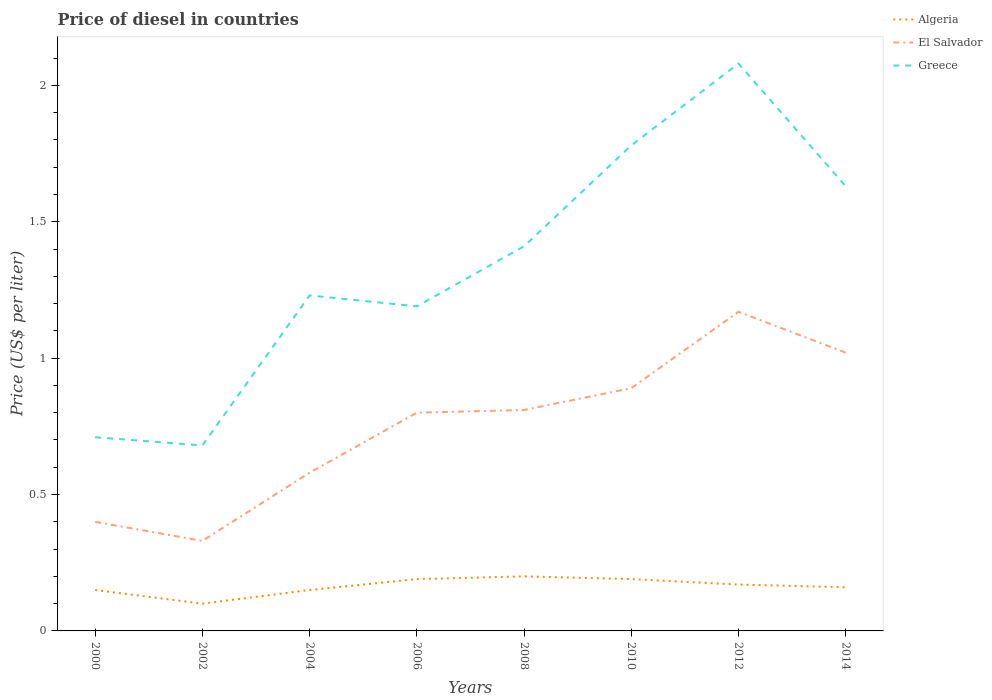How many different coloured lines are there?
Give a very brief answer. 3. Is the number of lines equal to the number of legend labels?
Make the answer very short. Yes. Across all years, what is the maximum price of diesel in Greece?
Your answer should be compact. 0.68. What is the total price of diesel in Algeria in the graph?
Your response must be concise. -0.01. Is the price of diesel in Algeria strictly greater than the price of diesel in Greece over the years?
Provide a short and direct response. Yes. How many lines are there?
Provide a succinct answer. 3. How many years are there in the graph?
Provide a short and direct response. 8. Are the values on the major ticks of Y-axis written in scientific E-notation?
Your answer should be compact. No. Does the graph contain any zero values?
Provide a succinct answer. No. Where does the legend appear in the graph?
Your response must be concise. Top right. How many legend labels are there?
Offer a very short reply. 3. How are the legend labels stacked?
Give a very brief answer. Vertical. What is the title of the graph?
Offer a terse response. Price of diesel in countries. Does "East Asia (developing only)" appear as one of the legend labels in the graph?
Your answer should be very brief. No. What is the label or title of the Y-axis?
Give a very brief answer. Price (US$ per liter). What is the Price (US$ per liter) in Algeria in 2000?
Your answer should be very brief. 0.15. What is the Price (US$ per liter) in Greece in 2000?
Provide a short and direct response. 0.71. What is the Price (US$ per liter) in El Salvador in 2002?
Your response must be concise. 0.33. What is the Price (US$ per liter) of Greece in 2002?
Offer a very short reply. 0.68. What is the Price (US$ per liter) in El Salvador in 2004?
Your answer should be very brief. 0.58. What is the Price (US$ per liter) in Greece in 2004?
Provide a short and direct response. 1.23. What is the Price (US$ per liter) in Algeria in 2006?
Keep it short and to the point. 0.19. What is the Price (US$ per liter) in Greece in 2006?
Your answer should be compact. 1.19. What is the Price (US$ per liter) of El Salvador in 2008?
Your answer should be very brief. 0.81. What is the Price (US$ per liter) in Greece in 2008?
Your response must be concise. 1.41. What is the Price (US$ per liter) in Algeria in 2010?
Provide a short and direct response. 0.19. What is the Price (US$ per liter) of El Salvador in 2010?
Your response must be concise. 0.89. What is the Price (US$ per liter) of Greece in 2010?
Provide a succinct answer. 1.78. What is the Price (US$ per liter) in Algeria in 2012?
Offer a very short reply. 0.17. What is the Price (US$ per liter) of El Salvador in 2012?
Give a very brief answer. 1.17. What is the Price (US$ per liter) in Greece in 2012?
Offer a terse response. 2.08. What is the Price (US$ per liter) in Algeria in 2014?
Ensure brevity in your answer.  0.16. What is the Price (US$ per liter) of El Salvador in 2014?
Your response must be concise. 1.02. What is the Price (US$ per liter) in Greece in 2014?
Provide a succinct answer. 1.63. Across all years, what is the maximum Price (US$ per liter) of El Salvador?
Make the answer very short. 1.17. Across all years, what is the maximum Price (US$ per liter) in Greece?
Provide a short and direct response. 2.08. Across all years, what is the minimum Price (US$ per liter) in Algeria?
Your response must be concise. 0.1. Across all years, what is the minimum Price (US$ per liter) of El Salvador?
Ensure brevity in your answer.  0.33. Across all years, what is the minimum Price (US$ per liter) of Greece?
Your answer should be compact. 0.68. What is the total Price (US$ per liter) of Algeria in the graph?
Your response must be concise. 1.31. What is the total Price (US$ per liter) in El Salvador in the graph?
Your answer should be compact. 6. What is the total Price (US$ per liter) in Greece in the graph?
Provide a short and direct response. 10.71. What is the difference between the Price (US$ per liter) of Algeria in 2000 and that in 2002?
Give a very brief answer. 0.05. What is the difference between the Price (US$ per liter) in El Salvador in 2000 and that in 2002?
Offer a terse response. 0.07. What is the difference between the Price (US$ per liter) in Greece in 2000 and that in 2002?
Your answer should be compact. 0.03. What is the difference between the Price (US$ per liter) of El Salvador in 2000 and that in 2004?
Offer a terse response. -0.18. What is the difference between the Price (US$ per liter) in Greece in 2000 and that in 2004?
Offer a terse response. -0.52. What is the difference between the Price (US$ per liter) of Algeria in 2000 and that in 2006?
Your answer should be very brief. -0.04. What is the difference between the Price (US$ per liter) of El Salvador in 2000 and that in 2006?
Keep it short and to the point. -0.4. What is the difference between the Price (US$ per liter) in Greece in 2000 and that in 2006?
Your answer should be compact. -0.48. What is the difference between the Price (US$ per liter) of El Salvador in 2000 and that in 2008?
Give a very brief answer. -0.41. What is the difference between the Price (US$ per liter) in Algeria in 2000 and that in 2010?
Keep it short and to the point. -0.04. What is the difference between the Price (US$ per liter) of El Salvador in 2000 and that in 2010?
Provide a succinct answer. -0.49. What is the difference between the Price (US$ per liter) of Greece in 2000 and that in 2010?
Offer a terse response. -1.07. What is the difference between the Price (US$ per liter) of Algeria in 2000 and that in 2012?
Offer a very short reply. -0.02. What is the difference between the Price (US$ per liter) in El Salvador in 2000 and that in 2012?
Provide a short and direct response. -0.77. What is the difference between the Price (US$ per liter) of Greece in 2000 and that in 2012?
Provide a succinct answer. -1.37. What is the difference between the Price (US$ per liter) of Algeria in 2000 and that in 2014?
Provide a succinct answer. -0.01. What is the difference between the Price (US$ per liter) of El Salvador in 2000 and that in 2014?
Provide a short and direct response. -0.62. What is the difference between the Price (US$ per liter) in Greece in 2000 and that in 2014?
Keep it short and to the point. -0.92. What is the difference between the Price (US$ per liter) in Algeria in 2002 and that in 2004?
Provide a short and direct response. -0.05. What is the difference between the Price (US$ per liter) in Greece in 2002 and that in 2004?
Offer a very short reply. -0.55. What is the difference between the Price (US$ per liter) of Algeria in 2002 and that in 2006?
Your response must be concise. -0.09. What is the difference between the Price (US$ per liter) in El Salvador in 2002 and that in 2006?
Make the answer very short. -0.47. What is the difference between the Price (US$ per liter) of Greece in 2002 and that in 2006?
Keep it short and to the point. -0.51. What is the difference between the Price (US$ per liter) in Algeria in 2002 and that in 2008?
Provide a succinct answer. -0.1. What is the difference between the Price (US$ per liter) of El Salvador in 2002 and that in 2008?
Give a very brief answer. -0.48. What is the difference between the Price (US$ per liter) in Greece in 2002 and that in 2008?
Ensure brevity in your answer.  -0.73. What is the difference between the Price (US$ per liter) in Algeria in 2002 and that in 2010?
Give a very brief answer. -0.09. What is the difference between the Price (US$ per liter) in El Salvador in 2002 and that in 2010?
Offer a terse response. -0.56. What is the difference between the Price (US$ per liter) of Algeria in 2002 and that in 2012?
Keep it short and to the point. -0.07. What is the difference between the Price (US$ per liter) in El Salvador in 2002 and that in 2012?
Offer a very short reply. -0.84. What is the difference between the Price (US$ per liter) of Greece in 2002 and that in 2012?
Provide a succinct answer. -1.4. What is the difference between the Price (US$ per liter) of Algeria in 2002 and that in 2014?
Your answer should be compact. -0.06. What is the difference between the Price (US$ per liter) in El Salvador in 2002 and that in 2014?
Keep it short and to the point. -0.69. What is the difference between the Price (US$ per liter) of Greece in 2002 and that in 2014?
Make the answer very short. -0.95. What is the difference between the Price (US$ per liter) of Algeria in 2004 and that in 2006?
Your response must be concise. -0.04. What is the difference between the Price (US$ per liter) of El Salvador in 2004 and that in 2006?
Provide a short and direct response. -0.22. What is the difference between the Price (US$ per liter) in El Salvador in 2004 and that in 2008?
Make the answer very short. -0.23. What is the difference between the Price (US$ per liter) in Greece in 2004 and that in 2008?
Keep it short and to the point. -0.18. What is the difference between the Price (US$ per liter) of Algeria in 2004 and that in 2010?
Make the answer very short. -0.04. What is the difference between the Price (US$ per liter) in El Salvador in 2004 and that in 2010?
Ensure brevity in your answer.  -0.31. What is the difference between the Price (US$ per liter) in Greece in 2004 and that in 2010?
Make the answer very short. -0.55. What is the difference between the Price (US$ per liter) in Algeria in 2004 and that in 2012?
Make the answer very short. -0.02. What is the difference between the Price (US$ per liter) in El Salvador in 2004 and that in 2012?
Keep it short and to the point. -0.59. What is the difference between the Price (US$ per liter) in Greece in 2004 and that in 2012?
Offer a very short reply. -0.85. What is the difference between the Price (US$ per liter) in Algeria in 2004 and that in 2014?
Your answer should be very brief. -0.01. What is the difference between the Price (US$ per liter) of El Salvador in 2004 and that in 2014?
Your answer should be compact. -0.44. What is the difference between the Price (US$ per liter) in Algeria in 2006 and that in 2008?
Provide a succinct answer. -0.01. What is the difference between the Price (US$ per liter) of El Salvador in 2006 and that in 2008?
Your answer should be compact. -0.01. What is the difference between the Price (US$ per liter) in Greece in 2006 and that in 2008?
Ensure brevity in your answer.  -0.22. What is the difference between the Price (US$ per liter) in Algeria in 2006 and that in 2010?
Keep it short and to the point. 0. What is the difference between the Price (US$ per liter) in El Salvador in 2006 and that in 2010?
Give a very brief answer. -0.09. What is the difference between the Price (US$ per liter) of Greece in 2006 and that in 2010?
Ensure brevity in your answer.  -0.59. What is the difference between the Price (US$ per liter) in Algeria in 2006 and that in 2012?
Ensure brevity in your answer.  0.02. What is the difference between the Price (US$ per liter) in El Salvador in 2006 and that in 2012?
Ensure brevity in your answer.  -0.37. What is the difference between the Price (US$ per liter) in Greece in 2006 and that in 2012?
Keep it short and to the point. -0.89. What is the difference between the Price (US$ per liter) of El Salvador in 2006 and that in 2014?
Your answer should be compact. -0.22. What is the difference between the Price (US$ per liter) in Greece in 2006 and that in 2014?
Your response must be concise. -0.44. What is the difference between the Price (US$ per liter) in El Salvador in 2008 and that in 2010?
Provide a succinct answer. -0.08. What is the difference between the Price (US$ per liter) of Greece in 2008 and that in 2010?
Give a very brief answer. -0.37. What is the difference between the Price (US$ per liter) in Algeria in 2008 and that in 2012?
Your answer should be compact. 0.03. What is the difference between the Price (US$ per liter) of El Salvador in 2008 and that in 2012?
Provide a succinct answer. -0.36. What is the difference between the Price (US$ per liter) in Greece in 2008 and that in 2012?
Give a very brief answer. -0.67. What is the difference between the Price (US$ per liter) in El Salvador in 2008 and that in 2014?
Ensure brevity in your answer.  -0.21. What is the difference between the Price (US$ per liter) of Greece in 2008 and that in 2014?
Your answer should be compact. -0.22. What is the difference between the Price (US$ per liter) of Algeria in 2010 and that in 2012?
Keep it short and to the point. 0.02. What is the difference between the Price (US$ per liter) of El Salvador in 2010 and that in 2012?
Make the answer very short. -0.28. What is the difference between the Price (US$ per liter) of Algeria in 2010 and that in 2014?
Offer a very short reply. 0.03. What is the difference between the Price (US$ per liter) of El Salvador in 2010 and that in 2014?
Make the answer very short. -0.13. What is the difference between the Price (US$ per liter) in Greece in 2010 and that in 2014?
Your answer should be very brief. 0.15. What is the difference between the Price (US$ per liter) of El Salvador in 2012 and that in 2014?
Keep it short and to the point. 0.15. What is the difference between the Price (US$ per liter) of Greece in 2012 and that in 2014?
Keep it short and to the point. 0.45. What is the difference between the Price (US$ per liter) in Algeria in 2000 and the Price (US$ per liter) in El Salvador in 2002?
Provide a succinct answer. -0.18. What is the difference between the Price (US$ per liter) in Algeria in 2000 and the Price (US$ per liter) in Greece in 2002?
Offer a very short reply. -0.53. What is the difference between the Price (US$ per liter) in El Salvador in 2000 and the Price (US$ per liter) in Greece in 2002?
Offer a very short reply. -0.28. What is the difference between the Price (US$ per liter) of Algeria in 2000 and the Price (US$ per liter) of El Salvador in 2004?
Your answer should be compact. -0.43. What is the difference between the Price (US$ per liter) of Algeria in 2000 and the Price (US$ per liter) of Greece in 2004?
Your answer should be compact. -1.08. What is the difference between the Price (US$ per liter) of El Salvador in 2000 and the Price (US$ per liter) of Greece in 2004?
Provide a short and direct response. -0.83. What is the difference between the Price (US$ per liter) in Algeria in 2000 and the Price (US$ per liter) in El Salvador in 2006?
Make the answer very short. -0.65. What is the difference between the Price (US$ per liter) in Algeria in 2000 and the Price (US$ per liter) in Greece in 2006?
Provide a succinct answer. -1.04. What is the difference between the Price (US$ per liter) of El Salvador in 2000 and the Price (US$ per liter) of Greece in 2006?
Provide a succinct answer. -0.79. What is the difference between the Price (US$ per liter) in Algeria in 2000 and the Price (US$ per liter) in El Salvador in 2008?
Give a very brief answer. -0.66. What is the difference between the Price (US$ per liter) of Algeria in 2000 and the Price (US$ per liter) of Greece in 2008?
Your answer should be very brief. -1.26. What is the difference between the Price (US$ per liter) of El Salvador in 2000 and the Price (US$ per liter) of Greece in 2008?
Offer a very short reply. -1.01. What is the difference between the Price (US$ per liter) in Algeria in 2000 and the Price (US$ per liter) in El Salvador in 2010?
Provide a short and direct response. -0.74. What is the difference between the Price (US$ per liter) in Algeria in 2000 and the Price (US$ per liter) in Greece in 2010?
Give a very brief answer. -1.63. What is the difference between the Price (US$ per liter) of El Salvador in 2000 and the Price (US$ per liter) of Greece in 2010?
Your response must be concise. -1.38. What is the difference between the Price (US$ per liter) in Algeria in 2000 and the Price (US$ per liter) in El Salvador in 2012?
Offer a terse response. -1.02. What is the difference between the Price (US$ per liter) in Algeria in 2000 and the Price (US$ per liter) in Greece in 2012?
Ensure brevity in your answer.  -1.93. What is the difference between the Price (US$ per liter) of El Salvador in 2000 and the Price (US$ per liter) of Greece in 2012?
Your answer should be very brief. -1.68. What is the difference between the Price (US$ per liter) of Algeria in 2000 and the Price (US$ per liter) of El Salvador in 2014?
Provide a short and direct response. -0.87. What is the difference between the Price (US$ per liter) of Algeria in 2000 and the Price (US$ per liter) of Greece in 2014?
Your answer should be compact. -1.48. What is the difference between the Price (US$ per liter) of El Salvador in 2000 and the Price (US$ per liter) of Greece in 2014?
Provide a short and direct response. -1.23. What is the difference between the Price (US$ per liter) in Algeria in 2002 and the Price (US$ per liter) in El Salvador in 2004?
Your response must be concise. -0.48. What is the difference between the Price (US$ per liter) of Algeria in 2002 and the Price (US$ per liter) of Greece in 2004?
Give a very brief answer. -1.13. What is the difference between the Price (US$ per liter) in Algeria in 2002 and the Price (US$ per liter) in Greece in 2006?
Offer a very short reply. -1.09. What is the difference between the Price (US$ per liter) in El Salvador in 2002 and the Price (US$ per liter) in Greece in 2006?
Ensure brevity in your answer.  -0.86. What is the difference between the Price (US$ per liter) in Algeria in 2002 and the Price (US$ per liter) in El Salvador in 2008?
Make the answer very short. -0.71. What is the difference between the Price (US$ per liter) in Algeria in 2002 and the Price (US$ per liter) in Greece in 2008?
Offer a terse response. -1.31. What is the difference between the Price (US$ per liter) of El Salvador in 2002 and the Price (US$ per liter) of Greece in 2008?
Offer a very short reply. -1.08. What is the difference between the Price (US$ per liter) of Algeria in 2002 and the Price (US$ per liter) of El Salvador in 2010?
Your answer should be very brief. -0.79. What is the difference between the Price (US$ per liter) in Algeria in 2002 and the Price (US$ per liter) in Greece in 2010?
Ensure brevity in your answer.  -1.68. What is the difference between the Price (US$ per liter) of El Salvador in 2002 and the Price (US$ per liter) of Greece in 2010?
Your response must be concise. -1.45. What is the difference between the Price (US$ per liter) of Algeria in 2002 and the Price (US$ per liter) of El Salvador in 2012?
Provide a short and direct response. -1.07. What is the difference between the Price (US$ per liter) in Algeria in 2002 and the Price (US$ per liter) in Greece in 2012?
Keep it short and to the point. -1.98. What is the difference between the Price (US$ per liter) of El Salvador in 2002 and the Price (US$ per liter) of Greece in 2012?
Offer a terse response. -1.75. What is the difference between the Price (US$ per liter) of Algeria in 2002 and the Price (US$ per liter) of El Salvador in 2014?
Give a very brief answer. -0.92. What is the difference between the Price (US$ per liter) in Algeria in 2002 and the Price (US$ per liter) in Greece in 2014?
Offer a very short reply. -1.53. What is the difference between the Price (US$ per liter) in Algeria in 2004 and the Price (US$ per liter) in El Salvador in 2006?
Provide a short and direct response. -0.65. What is the difference between the Price (US$ per liter) of Algeria in 2004 and the Price (US$ per liter) of Greece in 2006?
Your answer should be compact. -1.04. What is the difference between the Price (US$ per liter) in El Salvador in 2004 and the Price (US$ per liter) in Greece in 2006?
Keep it short and to the point. -0.61. What is the difference between the Price (US$ per liter) of Algeria in 2004 and the Price (US$ per liter) of El Salvador in 2008?
Make the answer very short. -0.66. What is the difference between the Price (US$ per liter) of Algeria in 2004 and the Price (US$ per liter) of Greece in 2008?
Your answer should be compact. -1.26. What is the difference between the Price (US$ per liter) in El Salvador in 2004 and the Price (US$ per liter) in Greece in 2008?
Your answer should be very brief. -0.83. What is the difference between the Price (US$ per liter) of Algeria in 2004 and the Price (US$ per liter) of El Salvador in 2010?
Keep it short and to the point. -0.74. What is the difference between the Price (US$ per liter) in Algeria in 2004 and the Price (US$ per liter) in Greece in 2010?
Your answer should be very brief. -1.63. What is the difference between the Price (US$ per liter) in Algeria in 2004 and the Price (US$ per liter) in El Salvador in 2012?
Your answer should be compact. -1.02. What is the difference between the Price (US$ per liter) in Algeria in 2004 and the Price (US$ per liter) in Greece in 2012?
Keep it short and to the point. -1.93. What is the difference between the Price (US$ per liter) of Algeria in 2004 and the Price (US$ per liter) of El Salvador in 2014?
Give a very brief answer. -0.87. What is the difference between the Price (US$ per liter) of Algeria in 2004 and the Price (US$ per liter) of Greece in 2014?
Give a very brief answer. -1.48. What is the difference between the Price (US$ per liter) of El Salvador in 2004 and the Price (US$ per liter) of Greece in 2014?
Your answer should be very brief. -1.05. What is the difference between the Price (US$ per liter) of Algeria in 2006 and the Price (US$ per liter) of El Salvador in 2008?
Make the answer very short. -0.62. What is the difference between the Price (US$ per liter) in Algeria in 2006 and the Price (US$ per liter) in Greece in 2008?
Your answer should be compact. -1.22. What is the difference between the Price (US$ per liter) in El Salvador in 2006 and the Price (US$ per liter) in Greece in 2008?
Ensure brevity in your answer.  -0.61. What is the difference between the Price (US$ per liter) of Algeria in 2006 and the Price (US$ per liter) of Greece in 2010?
Ensure brevity in your answer.  -1.59. What is the difference between the Price (US$ per liter) of El Salvador in 2006 and the Price (US$ per liter) of Greece in 2010?
Offer a terse response. -0.98. What is the difference between the Price (US$ per liter) in Algeria in 2006 and the Price (US$ per liter) in El Salvador in 2012?
Offer a very short reply. -0.98. What is the difference between the Price (US$ per liter) of Algeria in 2006 and the Price (US$ per liter) of Greece in 2012?
Your response must be concise. -1.89. What is the difference between the Price (US$ per liter) in El Salvador in 2006 and the Price (US$ per liter) in Greece in 2012?
Provide a succinct answer. -1.28. What is the difference between the Price (US$ per liter) of Algeria in 2006 and the Price (US$ per liter) of El Salvador in 2014?
Ensure brevity in your answer.  -0.83. What is the difference between the Price (US$ per liter) of Algeria in 2006 and the Price (US$ per liter) of Greece in 2014?
Your answer should be very brief. -1.44. What is the difference between the Price (US$ per liter) of El Salvador in 2006 and the Price (US$ per liter) of Greece in 2014?
Your response must be concise. -0.83. What is the difference between the Price (US$ per liter) of Algeria in 2008 and the Price (US$ per liter) of El Salvador in 2010?
Your answer should be compact. -0.69. What is the difference between the Price (US$ per liter) in Algeria in 2008 and the Price (US$ per liter) in Greece in 2010?
Keep it short and to the point. -1.58. What is the difference between the Price (US$ per liter) in El Salvador in 2008 and the Price (US$ per liter) in Greece in 2010?
Ensure brevity in your answer.  -0.97. What is the difference between the Price (US$ per liter) of Algeria in 2008 and the Price (US$ per liter) of El Salvador in 2012?
Your answer should be compact. -0.97. What is the difference between the Price (US$ per liter) in Algeria in 2008 and the Price (US$ per liter) in Greece in 2012?
Make the answer very short. -1.88. What is the difference between the Price (US$ per liter) of El Salvador in 2008 and the Price (US$ per liter) of Greece in 2012?
Make the answer very short. -1.27. What is the difference between the Price (US$ per liter) of Algeria in 2008 and the Price (US$ per liter) of El Salvador in 2014?
Provide a short and direct response. -0.82. What is the difference between the Price (US$ per liter) in Algeria in 2008 and the Price (US$ per liter) in Greece in 2014?
Make the answer very short. -1.43. What is the difference between the Price (US$ per liter) in El Salvador in 2008 and the Price (US$ per liter) in Greece in 2014?
Your answer should be very brief. -0.82. What is the difference between the Price (US$ per liter) in Algeria in 2010 and the Price (US$ per liter) in El Salvador in 2012?
Give a very brief answer. -0.98. What is the difference between the Price (US$ per liter) of Algeria in 2010 and the Price (US$ per liter) of Greece in 2012?
Offer a very short reply. -1.89. What is the difference between the Price (US$ per liter) of El Salvador in 2010 and the Price (US$ per liter) of Greece in 2012?
Provide a succinct answer. -1.19. What is the difference between the Price (US$ per liter) in Algeria in 2010 and the Price (US$ per liter) in El Salvador in 2014?
Make the answer very short. -0.83. What is the difference between the Price (US$ per liter) in Algeria in 2010 and the Price (US$ per liter) in Greece in 2014?
Your answer should be compact. -1.44. What is the difference between the Price (US$ per liter) of El Salvador in 2010 and the Price (US$ per liter) of Greece in 2014?
Keep it short and to the point. -0.74. What is the difference between the Price (US$ per liter) of Algeria in 2012 and the Price (US$ per liter) of El Salvador in 2014?
Offer a very short reply. -0.85. What is the difference between the Price (US$ per liter) of Algeria in 2012 and the Price (US$ per liter) of Greece in 2014?
Provide a succinct answer. -1.46. What is the difference between the Price (US$ per liter) in El Salvador in 2012 and the Price (US$ per liter) in Greece in 2014?
Provide a succinct answer. -0.46. What is the average Price (US$ per liter) in Algeria per year?
Offer a very short reply. 0.16. What is the average Price (US$ per liter) in El Salvador per year?
Ensure brevity in your answer.  0.75. What is the average Price (US$ per liter) in Greece per year?
Offer a terse response. 1.34. In the year 2000, what is the difference between the Price (US$ per liter) of Algeria and Price (US$ per liter) of El Salvador?
Your response must be concise. -0.25. In the year 2000, what is the difference between the Price (US$ per liter) of Algeria and Price (US$ per liter) of Greece?
Offer a very short reply. -0.56. In the year 2000, what is the difference between the Price (US$ per liter) in El Salvador and Price (US$ per liter) in Greece?
Offer a very short reply. -0.31. In the year 2002, what is the difference between the Price (US$ per liter) in Algeria and Price (US$ per liter) in El Salvador?
Keep it short and to the point. -0.23. In the year 2002, what is the difference between the Price (US$ per liter) in Algeria and Price (US$ per liter) in Greece?
Keep it short and to the point. -0.58. In the year 2002, what is the difference between the Price (US$ per liter) in El Salvador and Price (US$ per liter) in Greece?
Make the answer very short. -0.35. In the year 2004, what is the difference between the Price (US$ per liter) in Algeria and Price (US$ per liter) in El Salvador?
Ensure brevity in your answer.  -0.43. In the year 2004, what is the difference between the Price (US$ per liter) in Algeria and Price (US$ per liter) in Greece?
Ensure brevity in your answer.  -1.08. In the year 2004, what is the difference between the Price (US$ per liter) in El Salvador and Price (US$ per liter) in Greece?
Offer a terse response. -0.65. In the year 2006, what is the difference between the Price (US$ per liter) of Algeria and Price (US$ per liter) of El Salvador?
Ensure brevity in your answer.  -0.61. In the year 2006, what is the difference between the Price (US$ per liter) in Algeria and Price (US$ per liter) in Greece?
Keep it short and to the point. -1. In the year 2006, what is the difference between the Price (US$ per liter) of El Salvador and Price (US$ per liter) of Greece?
Offer a very short reply. -0.39. In the year 2008, what is the difference between the Price (US$ per liter) in Algeria and Price (US$ per liter) in El Salvador?
Offer a very short reply. -0.61. In the year 2008, what is the difference between the Price (US$ per liter) in Algeria and Price (US$ per liter) in Greece?
Ensure brevity in your answer.  -1.21. In the year 2008, what is the difference between the Price (US$ per liter) in El Salvador and Price (US$ per liter) in Greece?
Offer a very short reply. -0.6. In the year 2010, what is the difference between the Price (US$ per liter) in Algeria and Price (US$ per liter) in El Salvador?
Offer a terse response. -0.7. In the year 2010, what is the difference between the Price (US$ per liter) of Algeria and Price (US$ per liter) of Greece?
Give a very brief answer. -1.59. In the year 2010, what is the difference between the Price (US$ per liter) of El Salvador and Price (US$ per liter) of Greece?
Ensure brevity in your answer.  -0.89. In the year 2012, what is the difference between the Price (US$ per liter) in Algeria and Price (US$ per liter) in El Salvador?
Your answer should be compact. -1. In the year 2012, what is the difference between the Price (US$ per liter) in Algeria and Price (US$ per liter) in Greece?
Keep it short and to the point. -1.91. In the year 2012, what is the difference between the Price (US$ per liter) in El Salvador and Price (US$ per liter) in Greece?
Make the answer very short. -0.91. In the year 2014, what is the difference between the Price (US$ per liter) in Algeria and Price (US$ per liter) in El Salvador?
Provide a succinct answer. -0.86. In the year 2014, what is the difference between the Price (US$ per liter) of Algeria and Price (US$ per liter) of Greece?
Provide a succinct answer. -1.47. In the year 2014, what is the difference between the Price (US$ per liter) in El Salvador and Price (US$ per liter) in Greece?
Make the answer very short. -0.61. What is the ratio of the Price (US$ per liter) in Algeria in 2000 to that in 2002?
Your answer should be very brief. 1.5. What is the ratio of the Price (US$ per liter) of El Salvador in 2000 to that in 2002?
Provide a succinct answer. 1.21. What is the ratio of the Price (US$ per liter) of Greece in 2000 to that in 2002?
Offer a terse response. 1.04. What is the ratio of the Price (US$ per liter) of Algeria in 2000 to that in 2004?
Provide a short and direct response. 1. What is the ratio of the Price (US$ per liter) of El Salvador in 2000 to that in 2004?
Your answer should be compact. 0.69. What is the ratio of the Price (US$ per liter) in Greece in 2000 to that in 2004?
Offer a very short reply. 0.58. What is the ratio of the Price (US$ per liter) in Algeria in 2000 to that in 2006?
Ensure brevity in your answer.  0.79. What is the ratio of the Price (US$ per liter) of Greece in 2000 to that in 2006?
Your answer should be compact. 0.6. What is the ratio of the Price (US$ per liter) in Algeria in 2000 to that in 2008?
Give a very brief answer. 0.75. What is the ratio of the Price (US$ per liter) in El Salvador in 2000 to that in 2008?
Keep it short and to the point. 0.49. What is the ratio of the Price (US$ per liter) in Greece in 2000 to that in 2008?
Offer a terse response. 0.5. What is the ratio of the Price (US$ per liter) of Algeria in 2000 to that in 2010?
Your response must be concise. 0.79. What is the ratio of the Price (US$ per liter) in El Salvador in 2000 to that in 2010?
Make the answer very short. 0.45. What is the ratio of the Price (US$ per liter) in Greece in 2000 to that in 2010?
Give a very brief answer. 0.4. What is the ratio of the Price (US$ per liter) of Algeria in 2000 to that in 2012?
Your answer should be compact. 0.88. What is the ratio of the Price (US$ per liter) in El Salvador in 2000 to that in 2012?
Give a very brief answer. 0.34. What is the ratio of the Price (US$ per liter) of Greece in 2000 to that in 2012?
Offer a very short reply. 0.34. What is the ratio of the Price (US$ per liter) in El Salvador in 2000 to that in 2014?
Keep it short and to the point. 0.39. What is the ratio of the Price (US$ per liter) in Greece in 2000 to that in 2014?
Make the answer very short. 0.44. What is the ratio of the Price (US$ per liter) in El Salvador in 2002 to that in 2004?
Ensure brevity in your answer.  0.57. What is the ratio of the Price (US$ per liter) of Greece in 2002 to that in 2004?
Make the answer very short. 0.55. What is the ratio of the Price (US$ per liter) of Algeria in 2002 to that in 2006?
Ensure brevity in your answer.  0.53. What is the ratio of the Price (US$ per liter) in El Salvador in 2002 to that in 2006?
Give a very brief answer. 0.41. What is the ratio of the Price (US$ per liter) in Greece in 2002 to that in 2006?
Give a very brief answer. 0.57. What is the ratio of the Price (US$ per liter) of Algeria in 2002 to that in 2008?
Provide a succinct answer. 0.5. What is the ratio of the Price (US$ per liter) of El Salvador in 2002 to that in 2008?
Offer a terse response. 0.41. What is the ratio of the Price (US$ per liter) of Greece in 2002 to that in 2008?
Your response must be concise. 0.48. What is the ratio of the Price (US$ per liter) of Algeria in 2002 to that in 2010?
Your response must be concise. 0.53. What is the ratio of the Price (US$ per liter) in El Salvador in 2002 to that in 2010?
Offer a terse response. 0.37. What is the ratio of the Price (US$ per liter) in Greece in 2002 to that in 2010?
Give a very brief answer. 0.38. What is the ratio of the Price (US$ per liter) in Algeria in 2002 to that in 2012?
Make the answer very short. 0.59. What is the ratio of the Price (US$ per liter) of El Salvador in 2002 to that in 2012?
Your answer should be compact. 0.28. What is the ratio of the Price (US$ per liter) of Greece in 2002 to that in 2012?
Ensure brevity in your answer.  0.33. What is the ratio of the Price (US$ per liter) of Algeria in 2002 to that in 2014?
Provide a short and direct response. 0.62. What is the ratio of the Price (US$ per liter) of El Salvador in 2002 to that in 2014?
Your answer should be very brief. 0.32. What is the ratio of the Price (US$ per liter) of Greece in 2002 to that in 2014?
Ensure brevity in your answer.  0.42. What is the ratio of the Price (US$ per liter) in Algeria in 2004 to that in 2006?
Your response must be concise. 0.79. What is the ratio of the Price (US$ per liter) in El Salvador in 2004 to that in 2006?
Ensure brevity in your answer.  0.72. What is the ratio of the Price (US$ per liter) in Greece in 2004 to that in 2006?
Your response must be concise. 1.03. What is the ratio of the Price (US$ per liter) in El Salvador in 2004 to that in 2008?
Your answer should be compact. 0.72. What is the ratio of the Price (US$ per liter) in Greece in 2004 to that in 2008?
Provide a succinct answer. 0.87. What is the ratio of the Price (US$ per liter) of Algeria in 2004 to that in 2010?
Offer a very short reply. 0.79. What is the ratio of the Price (US$ per liter) in El Salvador in 2004 to that in 2010?
Ensure brevity in your answer.  0.65. What is the ratio of the Price (US$ per liter) in Greece in 2004 to that in 2010?
Keep it short and to the point. 0.69. What is the ratio of the Price (US$ per liter) in Algeria in 2004 to that in 2012?
Provide a succinct answer. 0.88. What is the ratio of the Price (US$ per liter) of El Salvador in 2004 to that in 2012?
Provide a short and direct response. 0.5. What is the ratio of the Price (US$ per liter) in Greece in 2004 to that in 2012?
Offer a terse response. 0.59. What is the ratio of the Price (US$ per liter) in Algeria in 2004 to that in 2014?
Provide a short and direct response. 0.94. What is the ratio of the Price (US$ per liter) in El Salvador in 2004 to that in 2014?
Your answer should be compact. 0.57. What is the ratio of the Price (US$ per liter) in Greece in 2004 to that in 2014?
Your response must be concise. 0.75. What is the ratio of the Price (US$ per liter) of El Salvador in 2006 to that in 2008?
Offer a very short reply. 0.99. What is the ratio of the Price (US$ per liter) in Greece in 2006 to that in 2008?
Give a very brief answer. 0.84. What is the ratio of the Price (US$ per liter) in El Salvador in 2006 to that in 2010?
Offer a terse response. 0.9. What is the ratio of the Price (US$ per liter) of Greece in 2006 to that in 2010?
Make the answer very short. 0.67. What is the ratio of the Price (US$ per liter) of Algeria in 2006 to that in 2012?
Your response must be concise. 1.12. What is the ratio of the Price (US$ per liter) in El Salvador in 2006 to that in 2012?
Ensure brevity in your answer.  0.68. What is the ratio of the Price (US$ per liter) in Greece in 2006 to that in 2012?
Provide a succinct answer. 0.57. What is the ratio of the Price (US$ per liter) in Algeria in 2006 to that in 2014?
Offer a very short reply. 1.19. What is the ratio of the Price (US$ per liter) in El Salvador in 2006 to that in 2014?
Your response must be concise. 0.78. What is the ratio of the Price (US$ per liter) of Greece in 2006 to that in 2014?
Ensure brevity in your answer.  0.73. What is the ratio of the Price (US$ per liter) in Algeria in 2008 to that in 2010?
Your answer should be compact. 1.05. What is the ratio of the Price (US$ per liter) in El Salvador in 2008 to that in 2010?
Make the answer very short. 0.91. What is the ratio of the Price (US$ per liter) in Greece in 2008 to that in 2010?
Provide a succinct answer. 0.79. What is the ratio of the Price (US$ per liter) of Algeria in 2008 to that in 2012?
Make the answer very short. 1.18. What is the ratio of the Price (US$ per liter) of El Salvador in 2008 to that in 2012?
Offer a very short reply. 0.69. What is the ratio of the Price (US$ per liter) in Greece in 2008 to that in 2012?
Your response must be concise. 0.68. What is the ratio of the Price (US$ per liter) of El Salvador in 2008 to that in 2014?
Keep it short and to the point. 0.79. What is the ratio of the Price (US$ per liter) of Greece in 2008 to that in 2014?
Offer a terse response. 0.86. What is the ratio of the Price (US$ per liter) of Algeria in 2010 to that in 2012?
Your answer should be compact. 1.12. What is the ratio of the Price (US$ per liter) in El Salvador in 2010 to that in 2012?
Provide a succinct answer. 0.76. What is the ratio of the Price (US$ per liter) of Greece in 2010 to that in 2012?
Your answer should be very brief. 0.86. What is the ratio of the Price (US$ per liter) in Algeria in 2010 to that in 2014?
Your answer should be very brief. 1.19. What is the ratio of the Price (US$ per liter) of El Salvador in 2010 to that in 2014?
Offer a terse response. 0.87. What is the ratio of the Price (US$ per liter) in Greece in 2010 to that in 2014?
Give a very brief answer. 1.09. What is the ratio of the Price (US$ per liter) in Algeria in 2012 to that in 2014?
Your answer should be very brief. 1.06. What is the ratio of the Price (US$ per liter) in El Salvador in 2012 to that in 2014?
Provide a short and direct response. 1.15. What is the ratio of the Price (US$ per liter) in Greece in 2012 to that in 2014?
Give a very brief answer. 1.28. What is the difference between the highest and the second highest Price (US$ per liter) of Algeria?
Provide a succinct answer. 0.01. What is the difference between the highest and the second highest Price (US$ per liter) of Greece?
Your answer should be very brief. 0.3. What is the difference between the highest and the lowest Price (US$ per liter) of Algeria?
Offer a very short reply. 0.1. What is the difference between the highest and the lowest Price (US$ per liter) of El Salvador?
Provide a short and direct response. 0.84. 